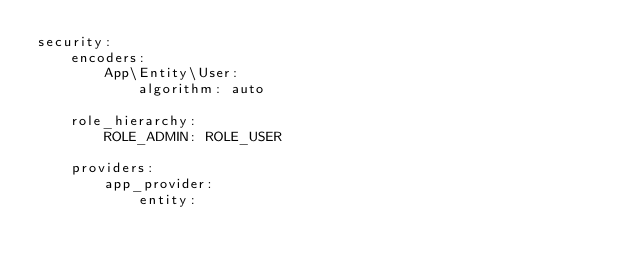<code> <loc_0><loc_0><loc_500><loc_500><_YAML_>security:
    encoders:
        App\Entity\User:
            algorithm: auto

    role_hierarchy:
        ROLE_ADMIN: ROLE_USER

    providers:
        app_provider:
            entity:</code> 